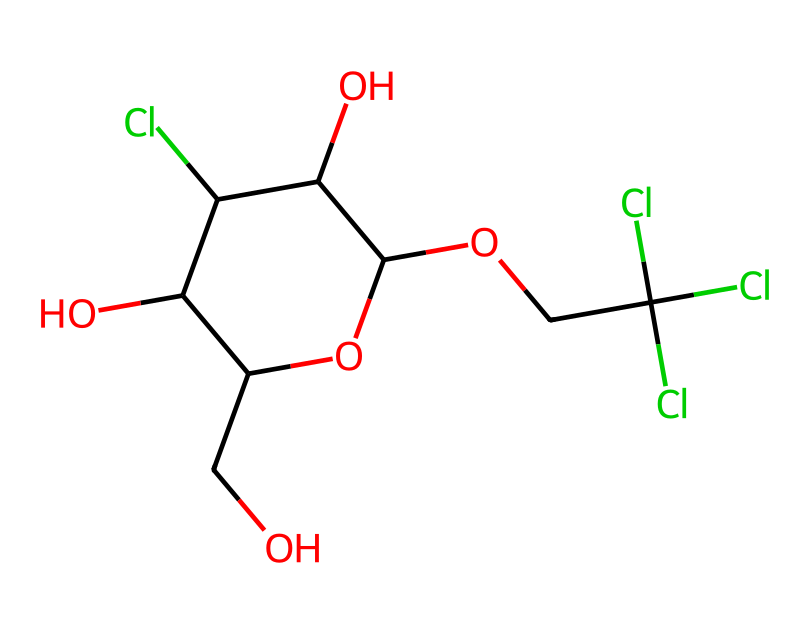What is the molecular formula of sucralose? The SMILES representation indicates the presence of carbon (C), oxygen (O), and chlorine (Cl) atoms. By translating the SMILES notation into a molecular formula, we count 12 carbon atoms, 19 hydrogen atoms, 8 oxygen atoms, and 3 chlorine atoms. This gives the molecular formula as C12H19Cl3O8.
Answer: C12H19Cl3O8 How many chlorine atoms are in sucralose? In the SMILES representation, we can identify the "Cl" notations indicating the presence of chlorine atoms. Counting these, we find there are three instances of "Cl."
Answer: 3 What type of chemical is sucralose classified as? Sucralose is specifically classified as an artificial sweetener, which is a type of food additive that provides sweetness without the calories associated with sucrose. Thus, it falls under the category of food additives.
Answer: artificial sweetener Does sucralose contain any chiral centers? To determine if there are any chiral centers, we look for carbon atoms that are attached to four different substituents. By visual inspection of the structure derived from the SMILES, we can identify multiple chiral centers marking at least 4 carbons with distinct attached groups.
Answer: yes What functional groups are present in sucralose? The SMILES representation shows several hydroxyl groups indicated by "O" connected to "C" as well as chlorinated carbon atoms. The presence of both hydroxyl (-OH) groups and halogens specifies that the functional groups include alcohols and halides.
Answer: alcohols and halides 